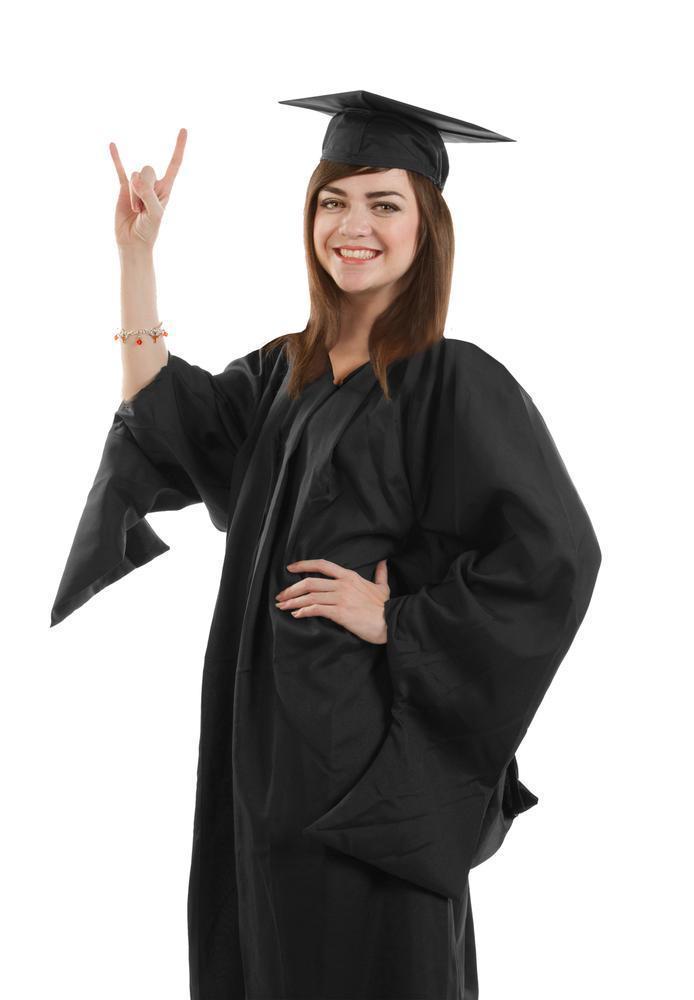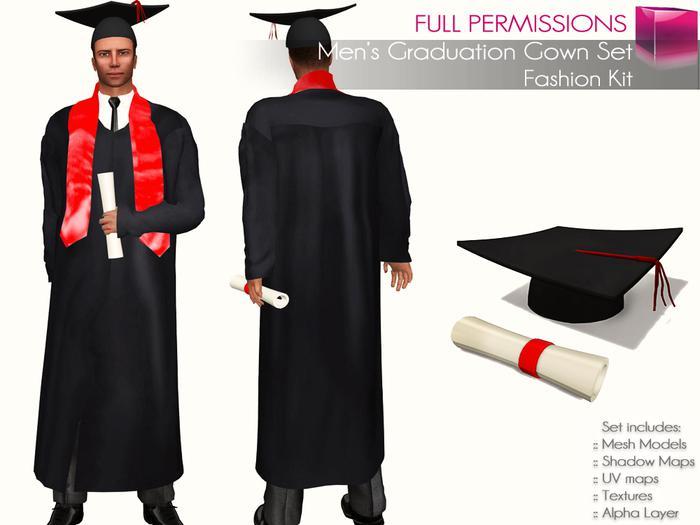The first image is the image on the left, the second image is the image on the right. Evaluate the accuracy of this statement regarding the images: "A woman stands with one hand on her hip.". Is it true? Answer yes or no. Yes. The first image is the image on the left, the second image is the image on the right. For the images shown, is this caption "The student in the right image is wearing a purple tie." true? Answer yes or no. No. 